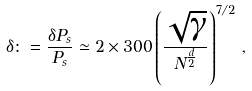<formula> <loc_0><loc_0><loc_500><loc_500>\delta \colon = \frac { \delta P _ { s } } { P _ { s } } \simeq 2 \times 3 0 0 \left ( \frac { \sqrt { \gamma } } { N ^ { \frac { d } { 2 } } } \right ) ^ { 7 / 2 } \, ,</formula> 